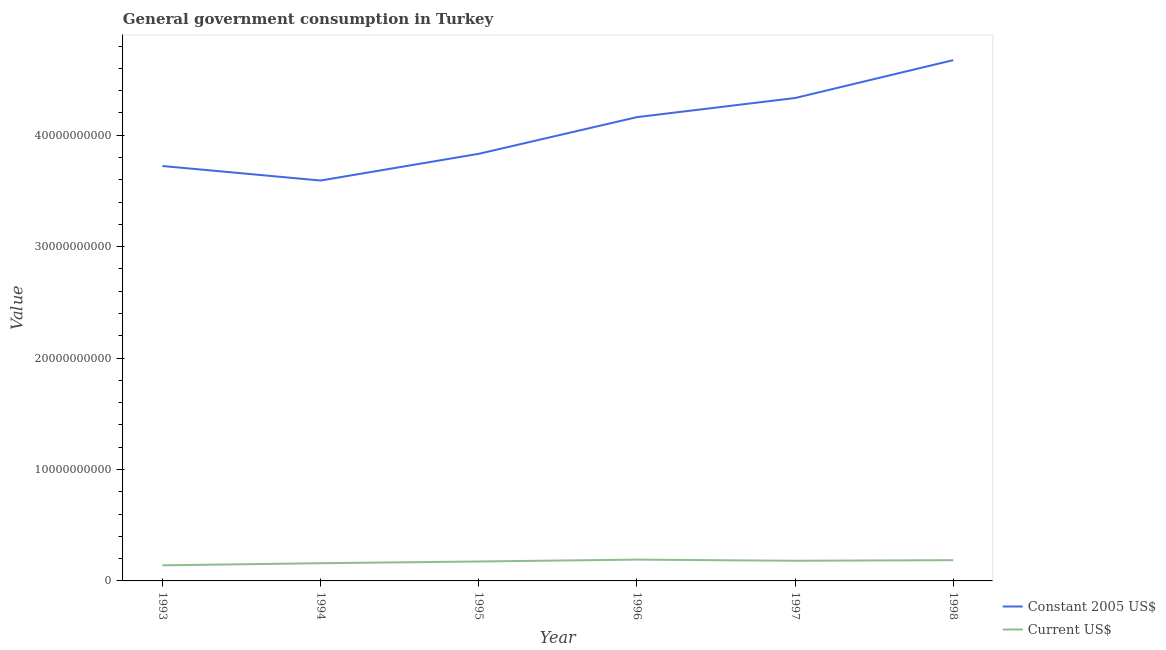Does the line corresponding to value consumed in current us$ intersect with the line corresponding to value consumed in constant 2005 us$?
Offer a very short reply. No. Is the number of lines equal to the number of legend labels?
Your answer should be very brief. Yes. What is the value consumed in current us$ in 1995?
Provide a short and direct response. 1.74e+09. Across all years, what is the maximum value consumed in current us$?
Your answer should be very brief. 1.91e+09. Across all years, what is the minimum value consumed in constant 2005 us$?
Your answer should be very brief. 3.59e+1. What is the total value consumed in current us$ in the graph?
Your response must be concise. 1.03e+1. What is the difference between the value consumed in constant 2005 us$ in 1995 and that in 1998?
Give a very brief answer. -8.41e+09. What is the difference between the value consumed in constant 2005 us$ in 1994 and the value consumed in current us$ in 1996?
Offer a very short reply. 3.40e+1. What is the average value consumed in constant 2005 us$ per year?
Your response must be concise. 4.05e+1. In the year 1997, what is the difference between the value consumed in current us$ and value consumed in constant 2005 us$?
Offer a terse response. -4.15e+1. In how many years, is the value consumed in constant 2005 us$ greater than 4000000000?
Give a very brief answer. 6. What is the ratio of the value consumed in constant 2005 us$ in 1993 to that in 1994?
Provide a succinct answer. 1.04. Is the value consumed in current us$ in 1996 less than that in 1998?
Make the answer very short. No. Is the difference between the value consumed in current us$ in 1993 and 1997 greater than the difference between the value consumed in constant 2005 us$ in 1993 and 1997?
Provide a short and direct response. Yes. What is the difference between the highest and the second highest value consumed in constant 2005 us$?
Your response must be concise. 3.40e+09. What is the difference between the highest and the lowest value consumed in current us$?
Make the answer very short. 5.11e+08. In how many years, is the value consumed in constant 2005 us$ greater than the average value consumed in constant 2005 us$ taken over all years?
Make the answer very short. 3. How many lines are there?
Ensure brevity in your answer.  2. How many years are there in the graph?
Offer a terse response. 6. Are the values on the major ticks of Y-axis written in scientific E-notation?
Your answer should be compact. No. Does the graph contain any zero values?
Offer a very short reply. No. Where does the legend appear in the graph?
Ensure brevity in your answer.  Bottom right. What is the title of the graph?
Your answer should be very brief. General government consumption in Turkey. What is the label or title of the X-axis?
Make the answer very short. Year. What is the label or title of the Y-axis?
Your response must be concise. Value. What is the Value in Constant 2005 US$ in 1993?
Offer a very short reply. 3.72e+1. What is the Value of Current US$ in 1993?
Provide a short and direct response. 1.40e+09. What is the Value in Constant 2005 US$ in 1994?
Provide a short and direct response. 3.59e+1. What is the Value of Current US$ in 1994?
Your response must be concise. 1.59e+09. What is the Value of Constant 2005 US$ in 1995?
Offer a very short reply. 3.83e+1. What is the Value in Current US$ in 1995?
Your answer should be compact. 1.74e+09. What is the Value of Constant 2005 US$ in 1996?
Give a very brief answer. 4.16e+1. What is the Value of Current US$ in 1996?
Your answer should be compact. 1.91e+09. What is the Value of Constant 2005 US$ in 1997?
Your response must be concise. 4.33e+1. What is the Value of Current US$ in 1997?
Ensure brevity in your answer.  1.81e+09. What is the Value in Constant 2005 US$ in 1998?
Your answer should be very brief. 4.67e+1. What is the Value in Current US$ in 1998?
Keep it short and to the point. 1.86e+09. Across all years, what is the maximum Value in Constant 2005 US$?
Keep it short and to the point. 4.67e+1. Across all years, what is the maximum Value in Current US$?
Keep it short and to the point. 1.91e+09. Across all years, what is the minimum Value of Constant 2005 US$?
Offer a very short reply. 3.59e+1. Across all years, what is the minimum Value in Current US$?
Your answer should be very brief. 1.40e+09. What is the total Value of Constant 2005 US$ in the graph?
Give a very brief answer. 2.43e+11. What is the total Value in Current US$ in the graph?
Provide a succinct answer. 1.03e+1. What is the difference between the Value in Constant 2005 US$ in 1993 and that in 1994?
Ensure brevity in your answer.  1.30e+09. What is the difference between the Value of Current US$ in 1993 and that in 1994?
Give a very brief answer. -1.89e+08. What is the difference between the Value of Constant 2005 US$ in 1993 and that in 1995?
Provide a succinct answer. -1.09e+09. What is the difference between the Value of Current US$ in 1993 and that in 1995?
Your answer should be compact. -3.44e+08. What is the difference between the Value in Constant 2005 US$ in 1993 and that in 1996?
Give a very brief answer. -4.39e+09. What is the difference between the Value in Current US$ in 1993 and that in 1996?
Your response must be concise. -5.11e+08. What is the difference between the Value of Constant 2005 US$ in 1993 and that in 1997?
Provide a succinct answer. -6.10e+09. What is the difference between the Value in Current US$ in 1993 and that in 1997?
Give a very brief answer. -4.09e+08. What is the difference between the Value in Constant 2005 US$ in 1993 and that in 1998?
Your response must be concise. -9.50e+09. What is the difference between the Value of Current US$ in 1993 and that in 1998?
Provide a short and direct response. -4.64e+08. What is the difference between the Value of Constant 2005 US$ in 1994 and that in 1995?
Give a very brief answer. -2.40e+09. What is the difference between the Value in Current US$ in 1994 and that in 1995?
Give a very brief answer. -1.56e+08. What is the difference between the Value in Constant 2005 US$ in 1994 and that in 1996?
Provide a succinct answer. -5.69e+09. What is the difference between the Value in Current US$ in 1994 and that in 1996?
Offer a terse response. -3.22e+08. What is the difference between the Value in Constant 2005 US$ in 1994 and that in 1997?
Ensure brevity in your answer.  -7.40e+09. What is the difference between the Value in Current US$ in 1994 and that in 1997?
Your answer should be compact. -2.20e+08. What is the difference between the Value in Constant 2005 US$ in 1994 and that in 1998?
Provide a succinct answer. -1.08e+1. What is the difference between the Value of Current US$ in 1994 and that in 1998?
Your response must be concise. -2.75e+08. What is the difference between the Value in Constant 2005 US$ in 1995 and that in 1996?
Provide a short and direct response. -3.29e+09. What is the difference between the Value of Current US$ in 1995 and that in 1996?
Your response must be concise. -1.67e+08. What is the difference between the Value of Constant 2005 US$ in 1995 and that in 1997?
Your answer should be very brief. -5.01e+09. What is the difference between the Value in Current US$ in 1995 and that in 1997?
Offer a very short reply. -6.43e+07. What is the difference between the Value in Constant 2005 US$ in 1995 and that in 1998?
Give a very brief answer. -8.41e+09. What is the difference between the Value of Current US$ in 1995 and that in 1998?
Your response must be concise. -1.19e+08. What is the difference between the Value of Constant 2005 US$ in 1996 and that in 1997?
Your answer should be compact. -1.72e+09. What is the difference between the Value of Current US$ in 1996 and that in 1997?
Provide a short and direct response. 1.02e+08. What is the difference between the Value of Constant 2005 US$ in 1996 and that in 1998?
Provide a short and direct response. -5.12e+09. What is the difference between the Value in Current US$ in 1996 and that in 1998?
Provide a short and direct response. 4.75e+07. What is the difference between the Value of Constant 2005 US$ in 1997 and that in 1998?
Your response must be concise. -3.40e+09. What is the difference between the Value in Current US$ in 1997 and that in 1998?
Your answer should be compact. -5.49e+07. What is the difference between the Value in Constant 2005 US$ in 1993 and the Value in Current US$ in 1994?
Offer a terse response. 3.57e+1. What is the difference between the Value in Constant 2005 US$ in 1993 and the Value in Current US$ in 1995?
Your response must be concise. 3.55e+1. What is the difference between the Value in Constant 2005 US$ in 1993 and the Value in Current US$ in 1996?
Offer a very short reply. 3.53e+1. What is the difference between the Value of Constant 2005 US$ in 1993 and the Value of Current US$ in 1997?
Provide a succinct answer. 3.54e+1. What is the difference between the Value of Constant 2005 US$ in 1993 and the Value of Current US$ in 1998?
Make the answer very short. 3.54e+1. What is the difference between the Value of Constant 2005 US$ in 1994 and the Value of Current US$ in 1995?
Offer a very short reply. 3.42e+1. What is the difference between the Value in Constant 2005 US$ in 1994 and the Value in Current US$ in 1996?
Offer a terse response. 3.40e+1. What is the difference between the Value in Constant 2005 US$ in 1994 and the Value in Current US$ in 1997?
Provide a short and direct response. 3.41e+1. What is the difference between the Value in Constant 2005 US$ in 1994 and the Value in Current US$ in 1998?
Provide a short and direct response. 3.41e+1. What is the difference between the Value of Constant 2005 US$ in 1995 and the Value of Current US$ in 1996?
Your response must be concise. 3.64e+1. What is the difference between the Value of Constant 2005 US$ in 1995 and the Value of Current US$ in 1997?
Offer a terse response. 3.65e+1. What is the difference between the Value in Constant 2005 US$ in 1995 and the Value in Current US$ in 1998?
Your answer should be very brief. 3.65e+1. What is the difference between the Value of Constant 2005 US$ in 1996 and the Value of Current US$ in 1997?
Offer a very short reply. 3.98e+1. What is the difference between the Value of Constant 2005 US$ in 1996 and the Value of Current US$ in 1998?
Provide a succinct answer. 3.98e+1. What is the difference between the Value of Constant 2005 US$ in 1997 and the Value of Current US$ in 1998?
Your answer should be compact. 4.15e+1. What is the average Value of Constant 2005 US$ per year?
Ensure brevity in your answer.  4.05e+1. What is the average Value in Current US$ per year?
Your answer should be compact. 1.72e+09. In the year 1993, what is the difference between the Value in Constant 2005 US$ and Value in Current US$?
Your response must be concise. 3.58e+1. In the year 1994, what is the difference between the Value of Constant 2005 US$ and Value of Current US$?
Offer a very short reply. 3.43e+1. In the year 1995, what is the difference between the Value of Constant 2005 US$ and Value of Current US$?
Offer a terse response. 3.66e+1. In the year 1996, what is the difference between the Value of Constant 2005 US$ and Value of Current US$?
Provide a short and direct response. 3.97e+1. In the year 1997, what is the difference between the Value in Constant 2005 US$ and Value in Current US$?
Offer a very short reply. 4.15e+1. In the year 1998, what is the difference between the Value of Constant 2005 US$ and Value of Current US$?
Your response must be concise. 4.49e+1. What is the ratio of the Value in Constant 2005 US$ in 1993 to that in 1994?
Your response must be concise. 1.04. What is the ratio of the Value of Current US$ in 1993 to that in 1994?
Offer a terse response. 0.88. What is the ratio of the Value in Constant 2005 US$ in 1993 to that in 1995?
Your answer should be compact. 0.97. What is the ratio of the Value in Current US$ in 1993 to that in 1995?
Provide a succinct answer. 0.8. What is the ratio of the Value of Constant 2005 US$ in 1993 to that in 1996?
Offer a very short reply. 0.89. What is the ratio of the Value in Current US$ in 1993 to that in 1996?
Give a very brief answer. 0.73. What is the ratio of the Value in Constant 2005 US$ in 1993 to that in 1997?
Ensure brevity in your answer.  0.86. What is the ratio of the Value in Current US$ in 1993 to that in 1997?
Offer a very short reply. 0.77. What is the ratio of the Value of Constant 2005 US$ in 1993 to that in 1998?
Your response must be concise. 0.8. What is the ratio of the Value in Current US$ in 1993 to that in 1998?
Provide a succinct answer. 0.75. What is the ratio of the Value of Constant 2005 US$ in 1994 to that in 1995?
Offer a terse response. 0.94. What is the ratio of the Value in Current US$ in 1994 to that in 1995?
Your answer should be compact. 0.91. What is the ratio of the Value of Constant 2005 US$ in 1994 to that in 1996?
Your answer should be very brief. 0.86. What is the ratio of the Value of Current US$ in 1994 to that in 1996?
Your answer should be very brief. 0.83. What is the ratio of the Value of Constant 2005 US$ in 1994 to that in 1997?
Your answer should be compact. 0.83. What is the ratio of the Value in Current US$ in 1994 to that in 1997?
Provide a short and direct response. 0.88. What is the ratio of the Value of Constant 2005 US$ in 1994 to that in 1998?
Your response must be concise. 0.77. What is the ratio of the Value in Current US$ in 1994 to that in 1998?
Keep it short and to the point. 0.85. What is the ratio of the Value in Constant 2005 US$ in 1995 to that in 1996?
Offer a very short reply. 0.92. What is the ratio of the Value of Current US$ in 1995 to that in 1996?
Make the answer very short. 0.91. What is the ratio of the Value of Constant 2005 US$ in 1995 to that in 1997?
Your response must be concise. 0.88. What is the ratio of the Value of Current US$ in 1995 to that in 1997?
Offer a very short reply. 0.96. What is the ratio of the Value of Constant 2005 US$ in 1995 to that in 1998?
Your answer should be very brief. 0.82. What is the ratio of the Value in Current US$ in 1995 to that in 1998?
Provide a succinct answer. 0.94. What is the ratio of the Value in Constant 2005 US$ in 1996 to that in 1997?
Give a very brief answer. 0.96. What is the ratio of the Value of Current US$ in 1996 to that in 1997?
Keep it short and to the point. 1.06. What is the ratio of the Value in Constant 2005 US$ in 1996 to that in 1998?
Your answer should be compact. 0.89. What is the ratio of the Value of Current US$ in 1996 to that in 1998?
Offer a very short reply. 1.03. What is the ratio of the Value in Constant 2005 US$ in 1997 to that in 1998?
Your response must be concise. 0.93. What is the ratio of the Value in Current US$ in 1997 to that in 1998?
Give a very brief answer. 0.97. What is the difference between the highest and the second highest Value in Constant 2005 US$?
Make the answer very short. 3.40e+09. What is the difference between the highest and the second highest Value in Current US$?
Keep it short and to the point. 4.75e+07. What is the difference between the highest and the lowest Value of Constant 2005 US$?
Give a very brief answer. 1.08e+1. What is the difference between the highest and the lowest Value of Current US$?
Offer a terse response. 5.11e+08. 